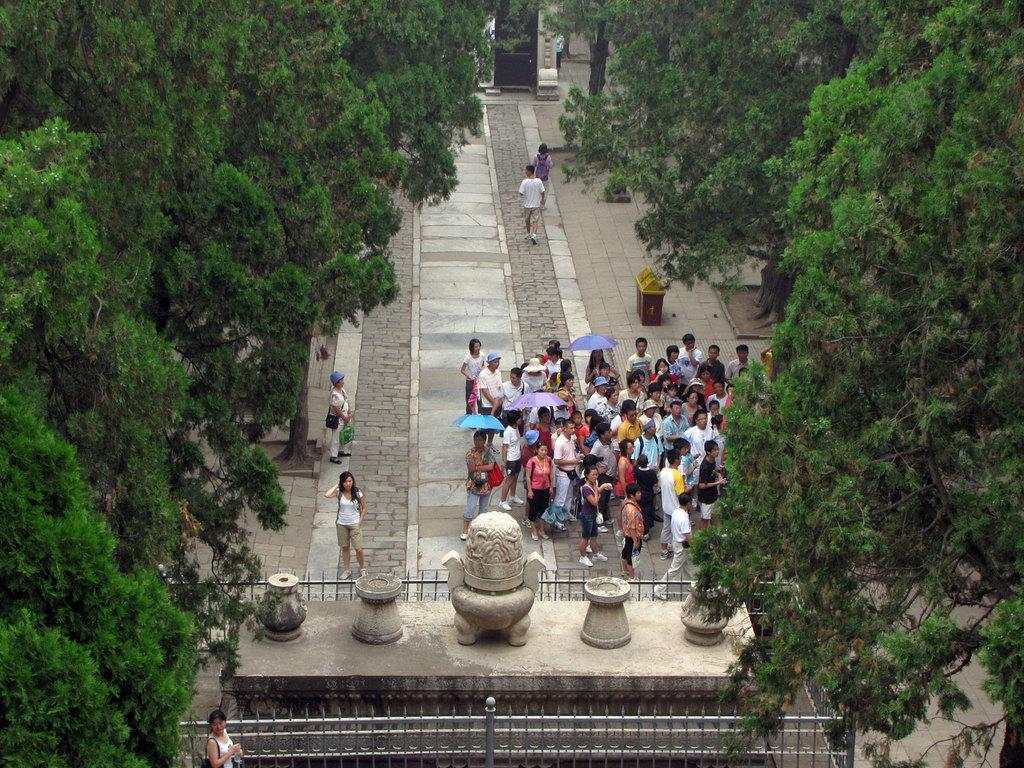How many people are in the image? There is a group of people in the image. What are some of the people in the image holding? Three people are holding umbrellas. What can be seen in the background of the image? There is a fence and trees in the image. What type of books are the people reading in the image? There are no books present in the image; the people are holding umbrellas. 